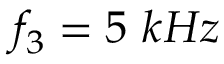<formula> <loc_0><loc_0><loc_500><loc_500>f _ { 3 } = 5 k H z</formula> 